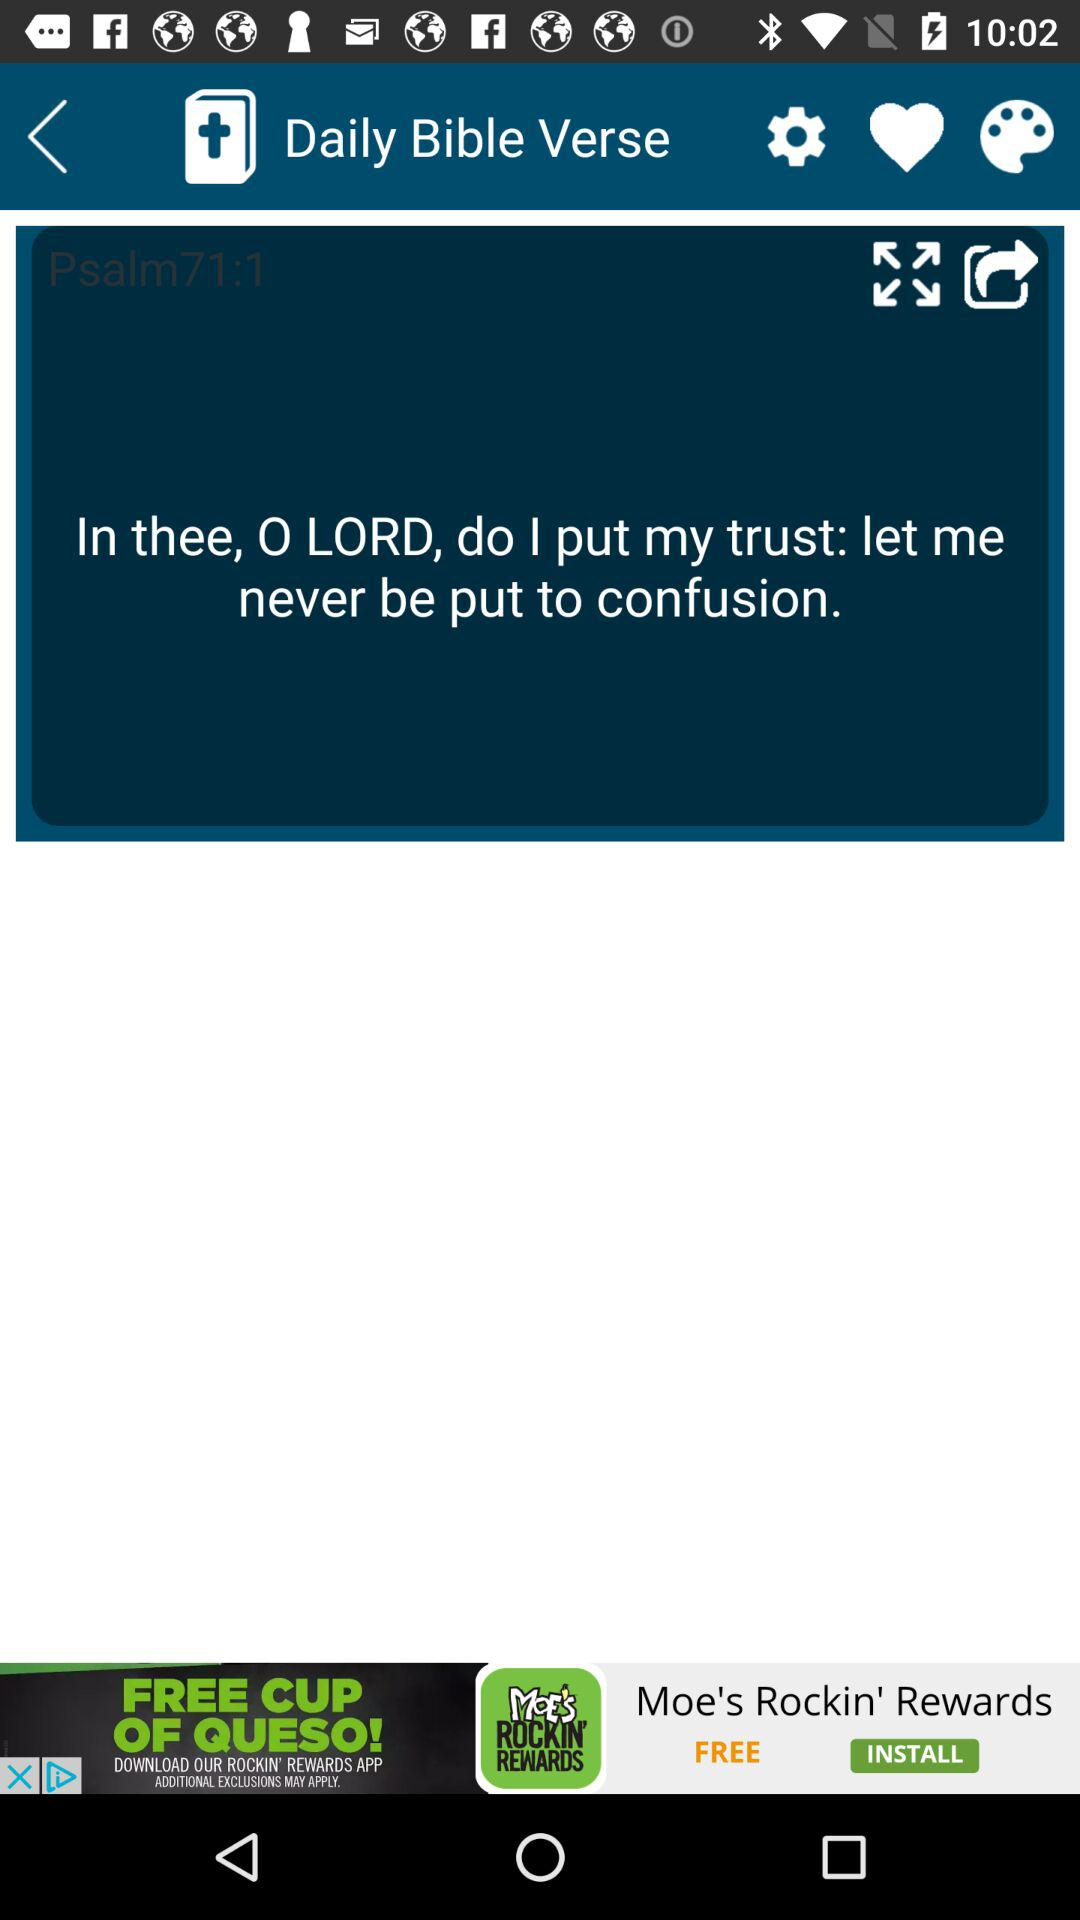When was the Bible verse posted?
When the provided information is insufficient, respond with <no answer>. <no answer> 